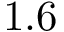<formula> <loc_0><loc_0><loc_500><loc_500>1 . 6</formula> 